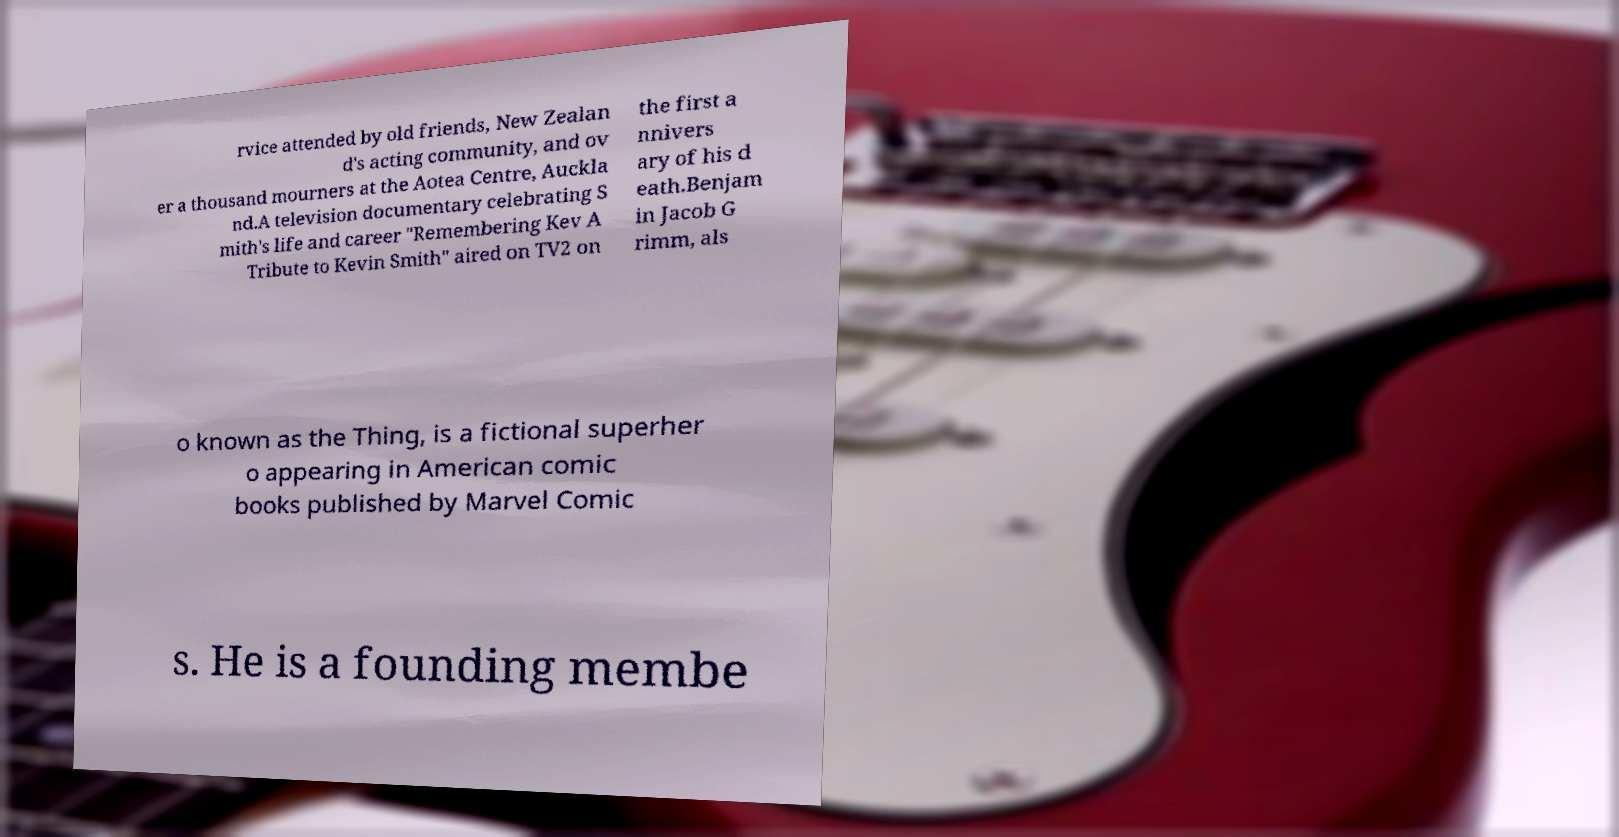For documentation purposes, I need the text within this image transcribed. Could you provide that? rvice attended by old friends, New Zealan d's acting community, and ov er a thousand mourners at the Aotea Centre, Auckla nd.A television documentary celebrating S mith's life and career "Remembering Kev A Tribute to Kevin Smith" aired on TV2 on the first a nnivers ary of his d eath.Benjam in Jacob G rimm, als o known as the Thing, is a fictional superher o appearing in American comic books published by Marvel Comic s. He is a founding membe 